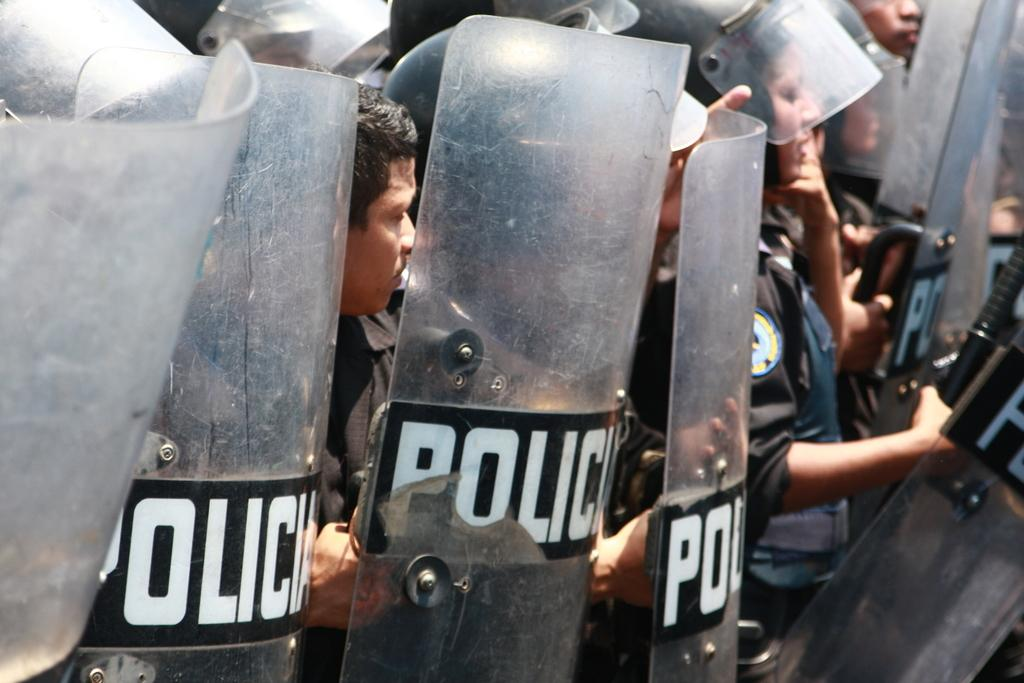What is the main subject of the image? The main subject of the image is a group of police. What are the police doing in the image? The police are taking charge against someone. What color are the uniforms of the police in the image? The police are wearing black uniforms. Where is the sink located in the image? There is no sink present in the image. What type of sheet is covering the field in the image? There is no sheet or field present in the image. 